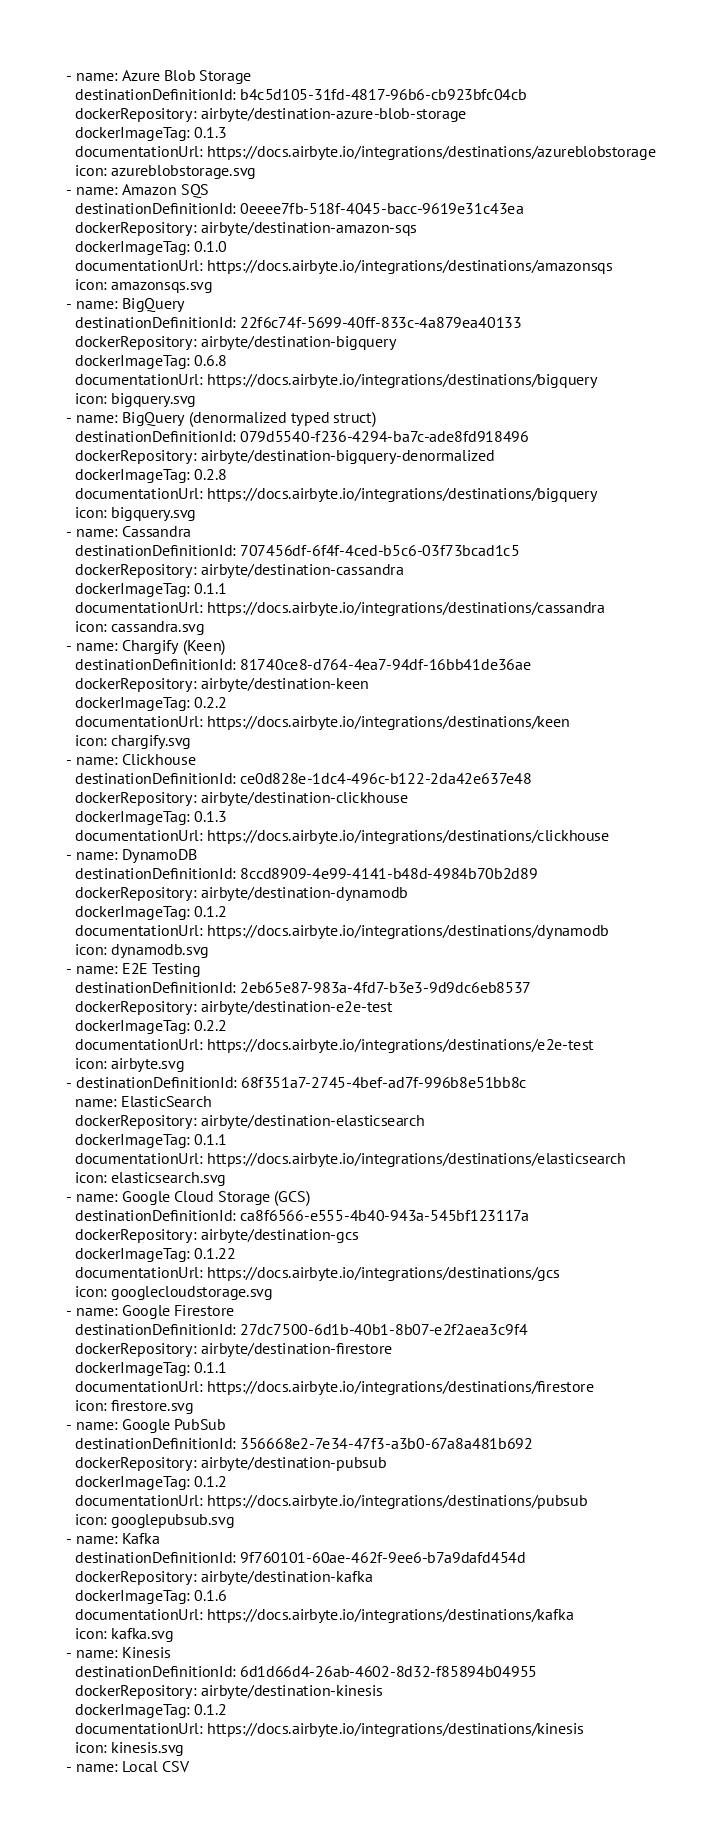Convert code to text. <code><loc_0><loc_0><loc_500><loc_500><_YAML_>- name: Azure Blob Storage
  destinationDefinitionId: b4c5d105-31fd-4817-96b6-cb923bfc04cb
  dockerRepository: airbyte/destination-azure-blob-storage
  dockerImageTag: 0.1.3
  documentationUrl: https://docs.airbyte.io/integrations/destinations/azureblobstorage
  icon: azureblobstorage.svg
- name: Amazon SQS
  destinationDefinitionId: 0eeee7fb-518f-4045-bacc-9619e31c43ea
  dockerRepository: airbyte/destination-amazon-sqs
  dockerImageTag: 0.1.0
  documentationUrl: https://docs.airbyte.io/integrations/destinations/amazonsqs
  icon: amazonsqs.svg
- name: BigQuery
  destinationDefinitionId: 22f6c74f-5699-40ff-833c-4a879ea40133
  dockerRepository: airbyte/destination-bigquery
  dockerImageTag: 0.6.8
  documentationUrl: https://docs.airbyte.io/integrations/destinations/bigquery
  icon: bigquery.svg
- name: BigQuery (denormalized typed struct)
  destinationDefinitionId: 079d5540-f236-4294-ba7c-ade8fd918496
  dockerRepository: airbyte/destination-bigquery-denormalized
  dockerImageTag: 0.2.8
  documentationUrl: https://docs.airbyte.io/integrations/destinations/bigquery
  icon: bigquery.svg
- name: Cassandra
  destinationDefinitionId: 707456df-6f4f-4ced-b5c6-03f73bcad1c5
  dockerRepository: airbyte/destination-cassandra
  dockerImageTag: 0.1.1
  documentationUrl: https://docs.airbyte.io/integrations/destinations/cassandra
  icon: cassandra.svg
- name: Chargify (Keen)
  destinationDefinitionId: 81740ce8-d764-4ea7-94df-16bb41de36ae
  dockerRepository: airbyte/destination-keen
  dockerImageTag: 0.2.2
  documentationUrl: https://docs.airbyte.io/integrations/destinations/keen
  icon: chargify.svg
- name: Clickhouse
  destinationDefinitionId: ce0d828e-1dc4-496c-b122-2da42e637e48
  dockerRepository: airbyte/destination-clickhouse
  dockerImageTag: 0.1.3
  documentationUrl: https://docs.airbyte.io/integrations/destinations/clickhouse
- name: DynamoDB
  destinationDefinitionId: 8ccd8909-4e99-4141-b48d-4984b70b2d89
  dockerRepository: airbyte/destination-dynamodb
  dockerImageTag: 0.1.2
  documentationUrl: https://docs.airbyte.io/integrations/destinations/dynamodb
  icon: dynamodb.svg
- name: E2E Testing
  destinationDefinitionId: 2eb65e87-983a-4fd7-b3e3-9d9dc6eb8537
  dockerRepository: airbyte/destination-e2e-test
  dockerImageTag: 0.2.2
  documentationUrl: https://docs.airbyte.io/integrations/destinations/e2e-test
  icon: airbyte.svg
- destinationDefinitionId: 68f351a7-2745-4bef-ad7f-996b8e51bb8c
  name: ElasticSearch
  dockerRepository: airbyte/destination-elasticsearch
  dockerImageTag: 0.1.1
  documentationUrl: https://docs.airbyte.io/integrations/destinations/elasticsearch
  icon: elasticsearch.svg
- name: Google Cloud Storage (GCS)
  destinationDefinitionId: ca8f6566-e555-4b40-943a-545bf123117a
  dockerRepository: airbyte/destination-gcs
  dockerImageTag: 0.1.22
  documentationUrl: https://docs.airbyte.io/integrations/destinations/gcs
  icon: googlecloudstorage.svg
- name: Google Firestore
  destinationDefinitionId: 27dc7500-6d1b-40b1-8b07-e2f2aea3c9f4
  dockerRepository: airbyte/destination-firestore
  dockerImageTag: 0.1.1
  documentationUrl: https://docs.airbyte.io/integrations/destinations/firestore
  icon: firestore.svg
- name: Google PubSub
  destinationDefinitionId: 356668e2-7e34-47f3-a3b0-67a8a481b692
  dockerRepository: airbyte/destination-pubsub
  dockerImageTag: 0.1.2
  documentationUrl: https://docs.airbyte.io/integrations/destinations/pubsub
  icon: googlepubsub.svg
- name: Kafka
  destinationDefinitionId: 9f760101-60ae-462f-9ee6-b7a9dafd454d
  dockerRepository: airbyte/destination-kafka
  dockerImageTag: 0.1.6
  documentationUrl: https://docs.airbyte.io/integrations/destinations/kafka
  icon: kafka.svg
- name: Kinesis
  destinationDefinitionId: 6d1d66d4-26ab-4602-8d32-f85894b04955
  dockerRepository: airbyte/destination-kinesis
  dockerImageTag: 0.1.2
  documentationUrl: https://docs.airbyte.io/integrations/destinations/kinesis
  icon: kinesis.svg
- name: Local CSV</code> 